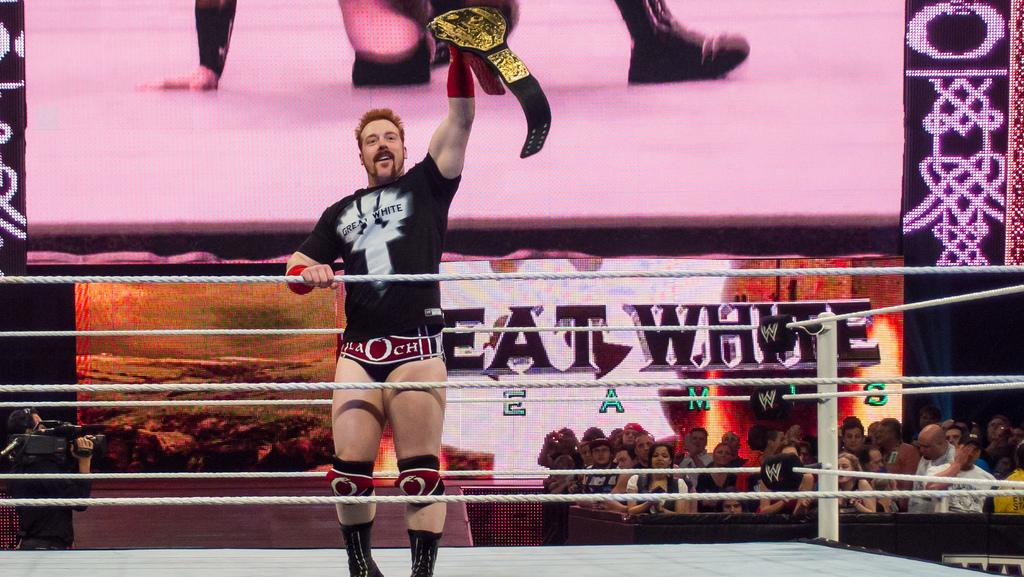<image>
Render a clear and concise summary of the photo. a wrester in the ring with a belt with the word eat behind him in black 